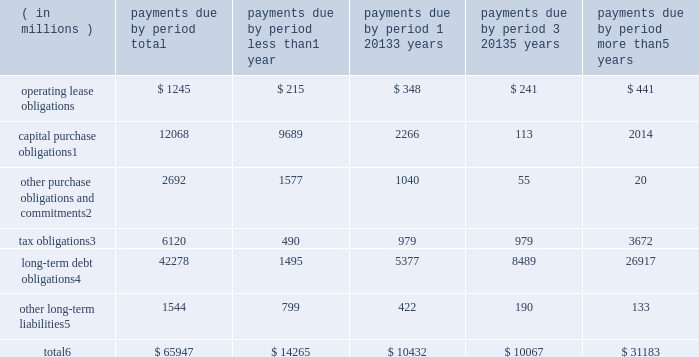Contractual obligations significant contractual obligations as of december 30 , 2017 were as follows: .
Capital purchase obligations1 12068 9689 2266 113 2014 other purchase obligations and commitments2 2692 1577 1040 55 20 tax obligations3 6120 490 979 979 3672 long-term debt obligations4 42278 1495 5377 8489 26917 other long-term liabilities5 1544 799 422 190 133 total6 $ 65947 $ 14265 $ 10432 $ 10067 $ 31183 1 capital purchase obligations represent commitments for the construction or purchase of property , plant and equipment .
They were not recorded as liabilities on our consolidated balance sheets as of december 30 , 2017 , as we had not yet received the related goods nor taken title to the property .
2 other purchase obligations and commitments include payments due under various types of licenses and agreements to purchase goods or services , as well as payments due under non-contingent funding obligations .
3 tax obligations represent the future cash payments related to tax reform enacted in 2017 for the one-time provisional transition tax on our previously untaxed foreign earnings .
For further information , see 201cnote 8 : income taxes 201d within the consolidated financial statements .
4 amounts represent principal and interest cash payments over the life of the debt obligations , including anticipated interest payments that are not recorded on our consolidated balance sheets .
Debt obligations are classified based on their stated maturity date , regardless of their classification on the consolidated balance sheets .
Any future settlement of convertible debt would impact our cash payments .
5 amounts represent future cash payments to satisfy other long-term liabilities recorded on our consolidated balance sheets , including the short-term portion of these long-term liabilities .
Derivative instruments are excluded from the preceding table , as they do not represent the amounts that may ultimately be paid .
6 total excludes contractual obligations already recorded on our consolidated balance sheets as current liabilities , except for the short-term portions of long-term debt obligations and other long-term liabilities .
The expected timing of payments of the obligations in the preceding table is estimated based on current information .
Timing of payments and actual amounts paid may be different , depending on the time of receipt of goods or services , or changes to agreed- upon amounts for some obligations .
Contractual obligations for purchases of goods or services included in 201cother purchase obligations and commitments 201d in the preceding table include agreements that are enforceable and legally binding on intel and that specify all significant terms , including fixed or minimum quantities to be purchased ; fixed , minimum , or variable price provisions ; and the approximate timing of the transaction .
For obligations with cancellation provisions , the amounts included in the preceding table were limited to the non-cancelable portion of the agreement terms or the minimum cancellation fee .
For the purchase of raw materials , we have entered into certain agreements that specify minimum prices and quantities based on a percentage of the total available market or based on a percentage of our future purchasing requirements .
Due to the uncertainty of the future market and our future purchasing requirements , as well as the non-binding nature of these agreements , obligations under these agreements have been excluded from the preceding table .
Our purchase orders for other products are based on our current manufacturing needs and are fulfilled by our vendors within short time horizons .
In addition , some of our purchase orders represent authorizations to purchase rather than binding agreements .
Contractual obligations that are contingent upon the achievement of certain milestones have been excluded from the preceding table .
Most of our milestone-based contracts are tooling related for the purchase of capital equipment .
These arrangements are not considered contractual obligations until the milestone is met by the counterparty .
As of december 30 , 2017 , assuming that all future milestones are met , the additional required payments would be approximately $ 2.0 billion .
For the majority of restricted stock units ( rsus ) granted , the number of shares of common stock issued on the date the rsus vest is net of the minimum statutory withholding requirements that we pay in cash to the appropriate taxing authorities on behalf of our employees .
The obligation to pay the relevant taxing authority is excluded from the preceding table , as the amount is contingent upon continued employment .
In addition , the amount of the obligation is unknown , as it is based in part on the market price of our common stock when the awards vest .
Md&a - results of operations consolidated results and analysis 38 .
What percentage of total contractual obligations do long-term debt obligations make up as of december 30 2017? 
Computations: (42278 / 65947)
Answer: 0.64109. 